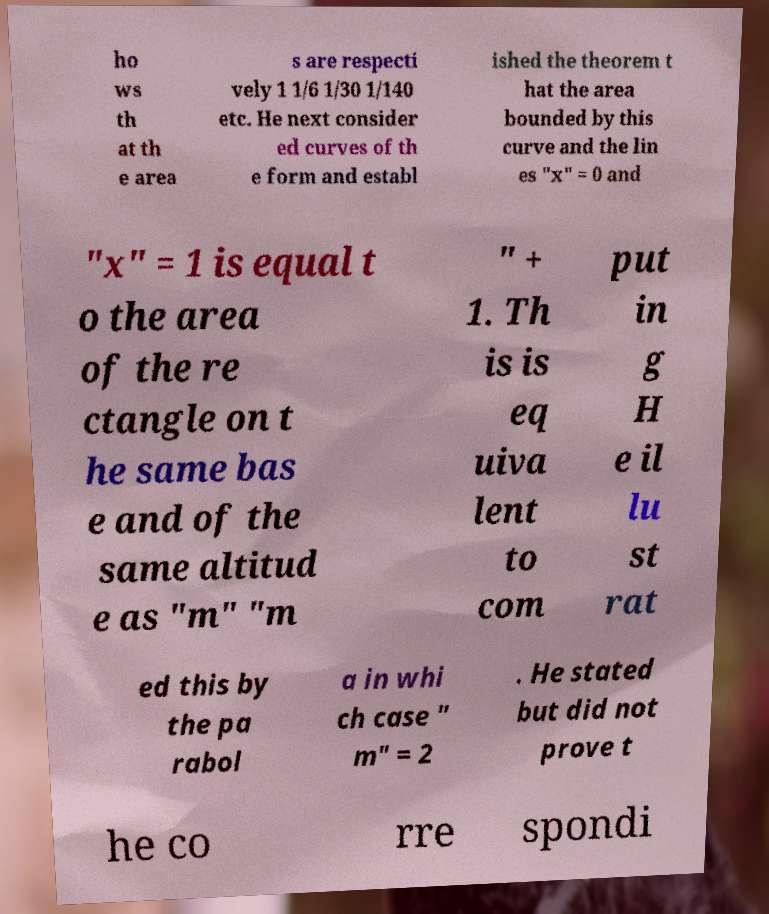Could you extract and type out the text from this image? ho ws th at th e area s are respecti vely 1 1/6 1/30 1/140 etc. He next consider ed curves of th e form and establ ished the theorem t hat the area bounded by this curve and the lin es "x" = 0 and "x" = 1 is equal t o the area of the re ctangle on t he same bas e and of the same altitud e as "m" "m " + 1. Th is is eq uiva lent to com put in g H e il lu st rat ed this by the pa rabol a in whi ch case " m" = 2 . He stated but did not prove t he co rre spondi 